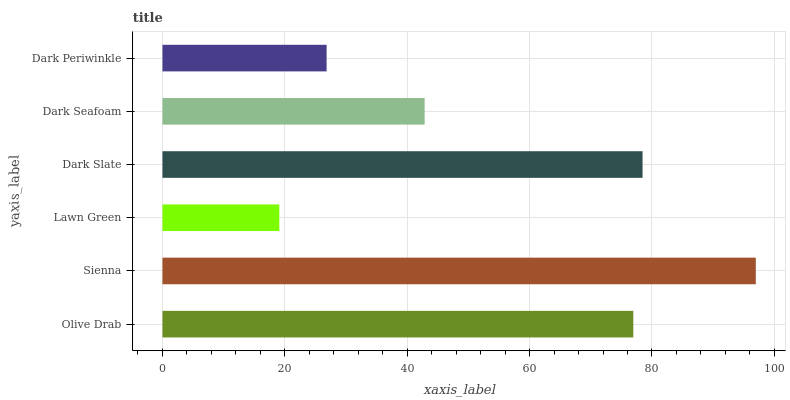Is Lawn Green the minimum?
Answer yes or no. Yes. Is Sienna the maximum?
Answer yes or no. Yes. Is Sienna the minimum?
Answer yes or no. No. Is Lawn Green the maximum?
Answer yes or no. No. Is Sienna greater than Lawn Green?
Answer yes or no. Yes. Is Lawn Green less than Sienna?
Answer yes or no. Yes. Is Lawn Green greater than Sienna?
Answer yes or no. No. Is Sienna less than Lawn Green?
Answer yes or no. No. Is Olive Drab the high median?
Answer yes or no. Yes. Is Dark Seafoam the low median?
Answer yes or no. Yes. Is Sienna the high median?
Answer yes or no. No. Is Sienna the low median?
Answer yes or no. No. 